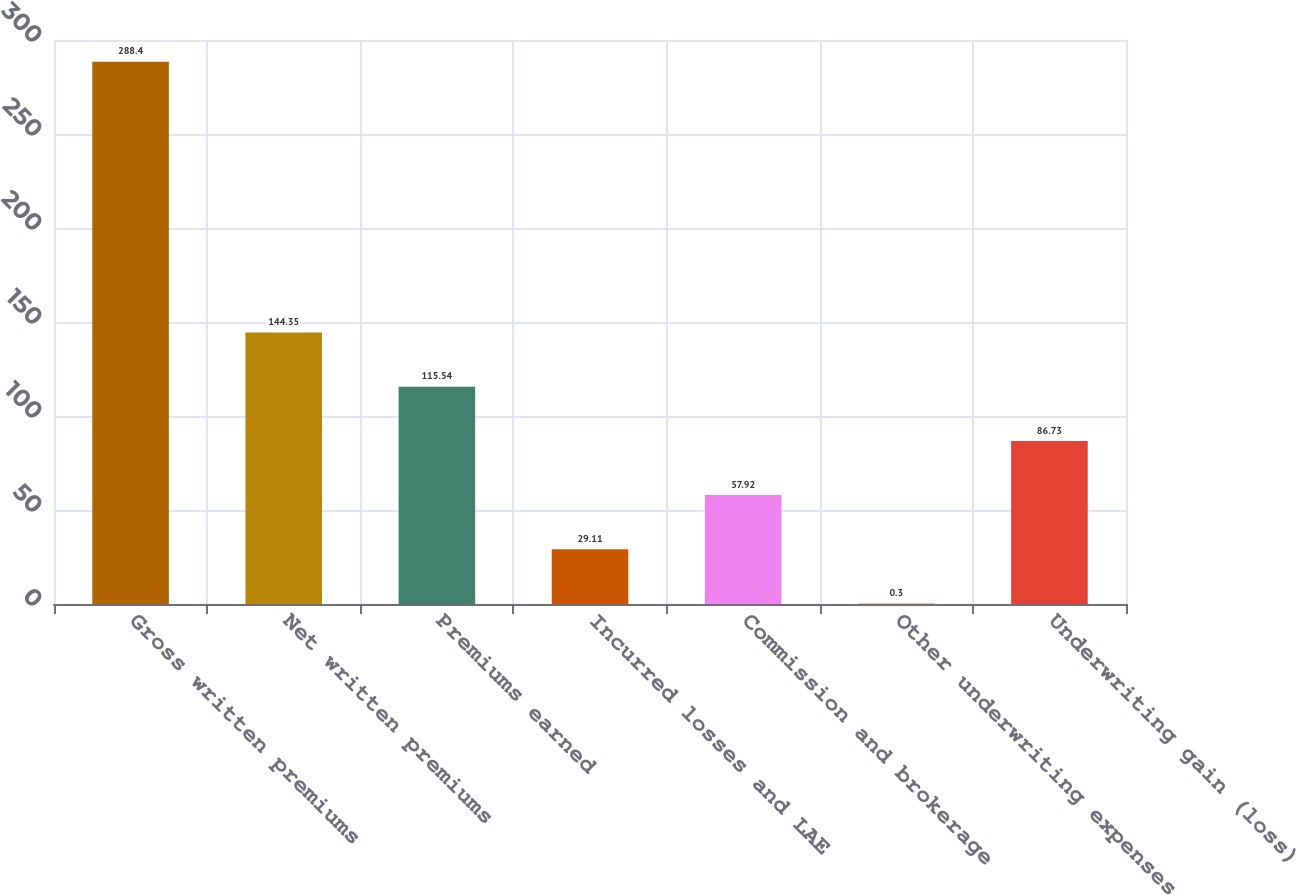Convert chart to OTSL. <chart><loc_0><loc_0><loc_500><loc_500><bar_chart><fcel>Gross written premiums<fcel>Net written premiums<fcel>Premiums earned<fcel>Incurred losses and LAE<fcel>Commission and brokerage<fcel>Other underwriting expenses<fcel>Underwriting gain (loss)<nl><fcel>288.4<fcel>144.35<fcel>115.54<fcel>29.11<fcel>57.92<fcel>0.3<fcel>86.73<nl></chart> 